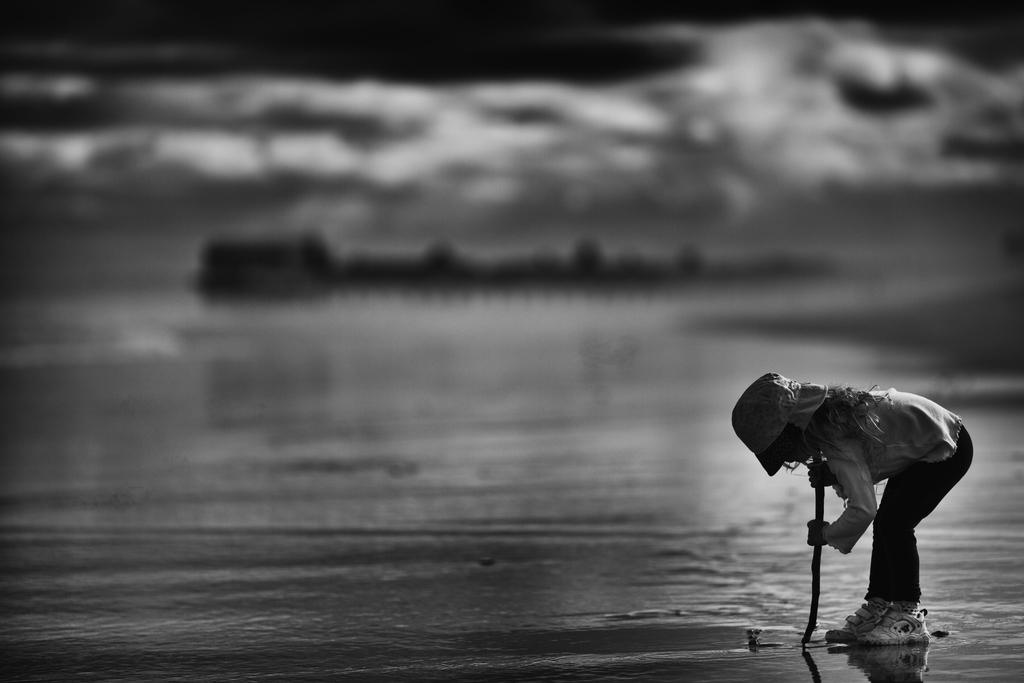Where is the child located in the image? The child is on the right side of the image. What is the child wearing on their head? The child is wearing a cap. What is the child holding in their hand? The child is holding a stick. What position is the child in? The child is bending on the ground. What is the condition of the ground in the image? The ground is wet. How would you describe the background of the image? The background of the image is blurred. What type of stew is being prepared in the background of the image? There is no stew being prepared in the image; the background is blurred. What is the child's interest in the seashore, as seen in the image? There is no seashore present in the image, so it is not possible to determine the child's interest in it. 